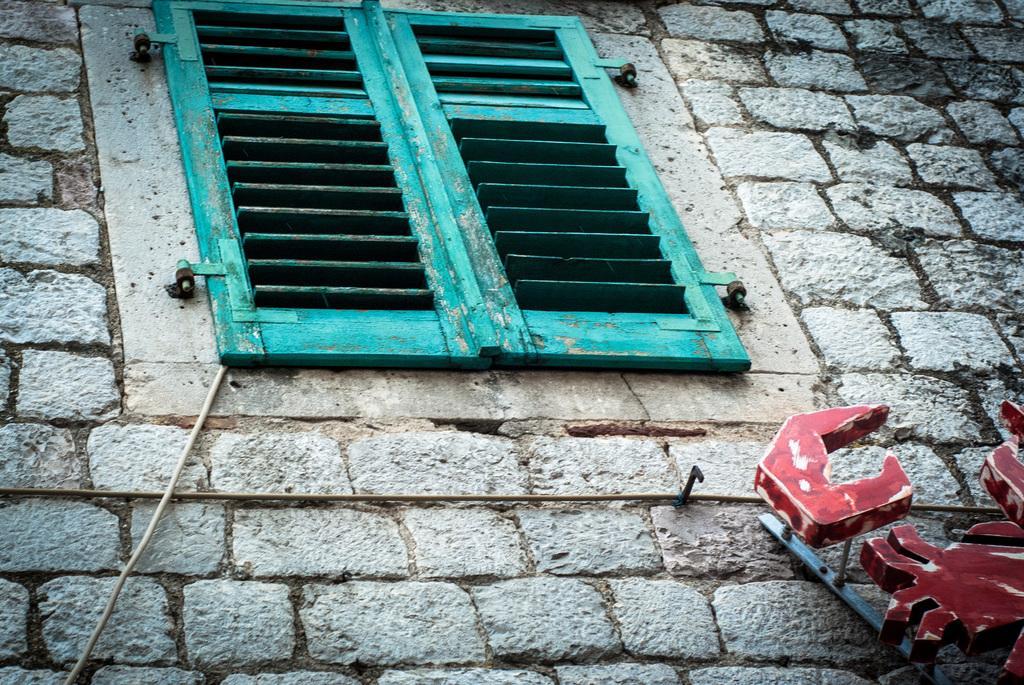In one or two sentences, can you explain what this image depicts? In this image we can see a wall made of bricks, there is a wooden window on it, a wire is going through the window, and we can see an object on the wall. 